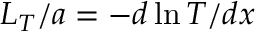Convert formula to latex. <formula><loc_0><loc_0><loc_500><loc_500>L _ { T } / a = - d \ln T / d x</formula> 